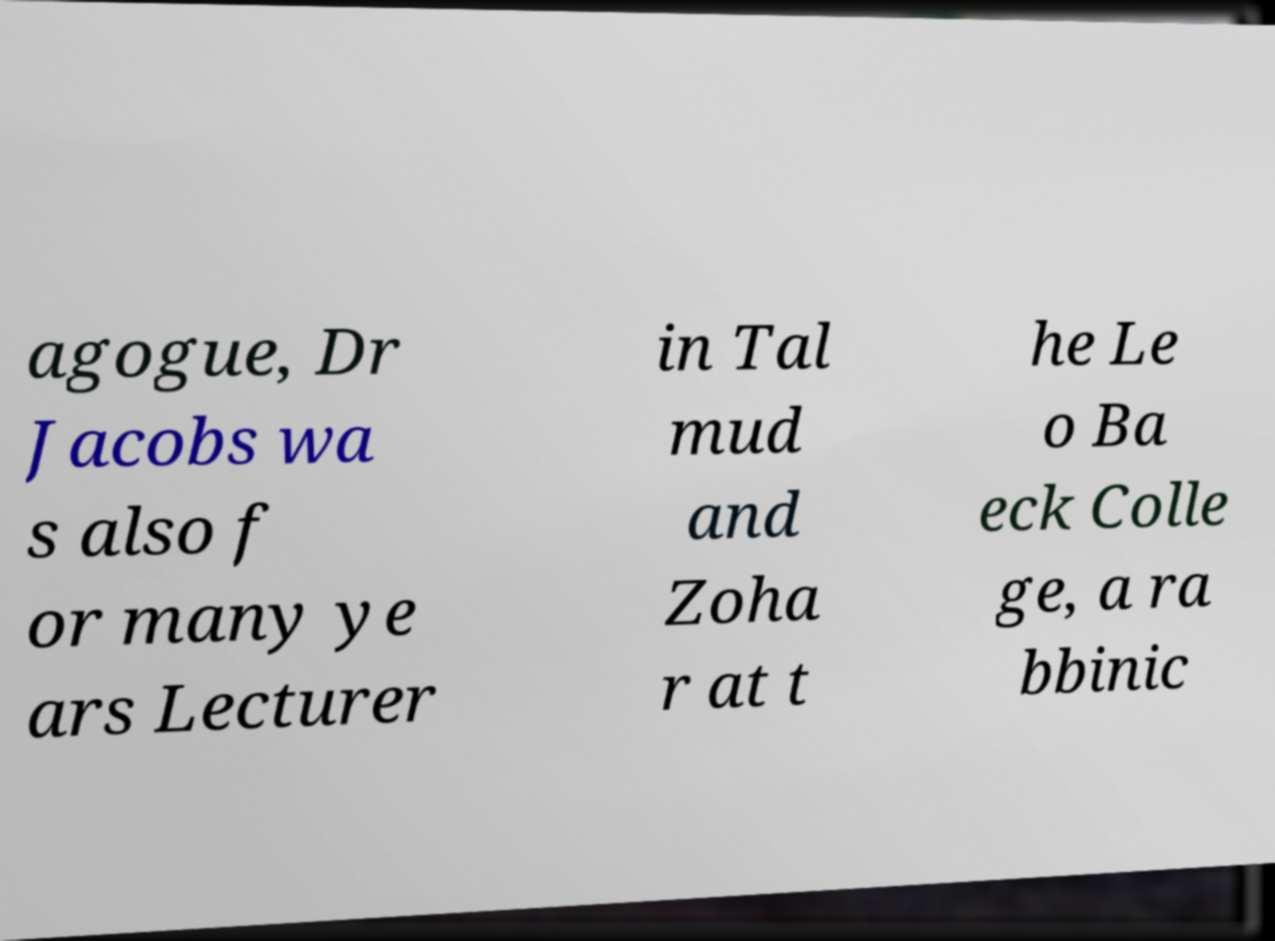There's text embedded in this image that I need extracted. Can you transcribe it verbatim? agogue, Dr Jacobs wa s also f or many ye ars Lecturer in Tal mud and Zoha r at t he Le o Ba eck Colle ge, a ra bbinic 